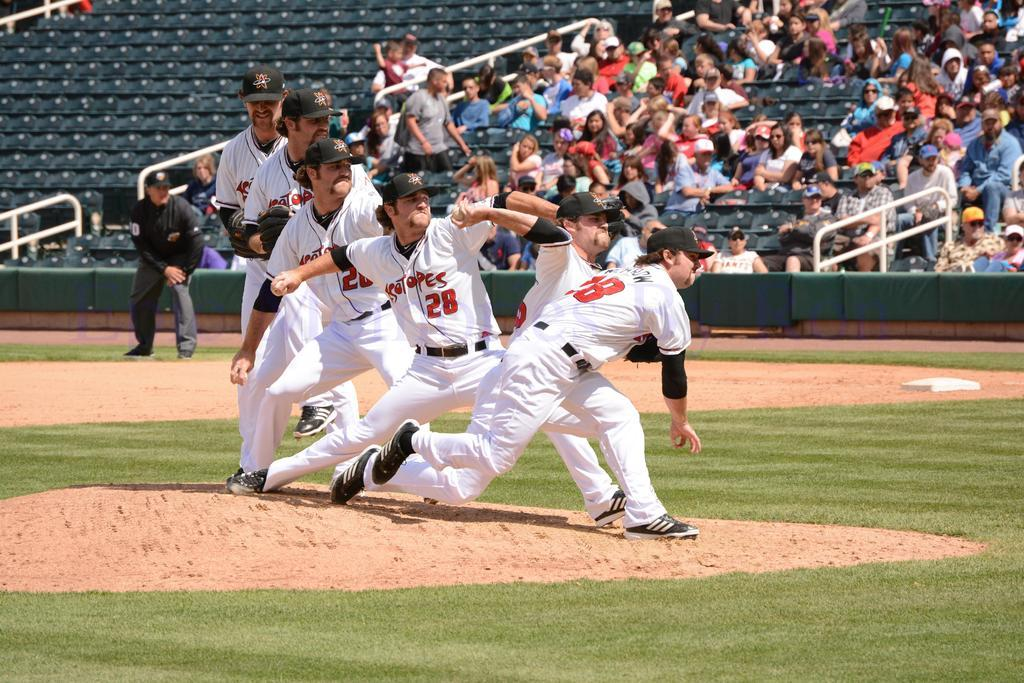<image>
Relay a brief, clear account of the picture shown. Player number 28 winds up and pitches the baseball. 